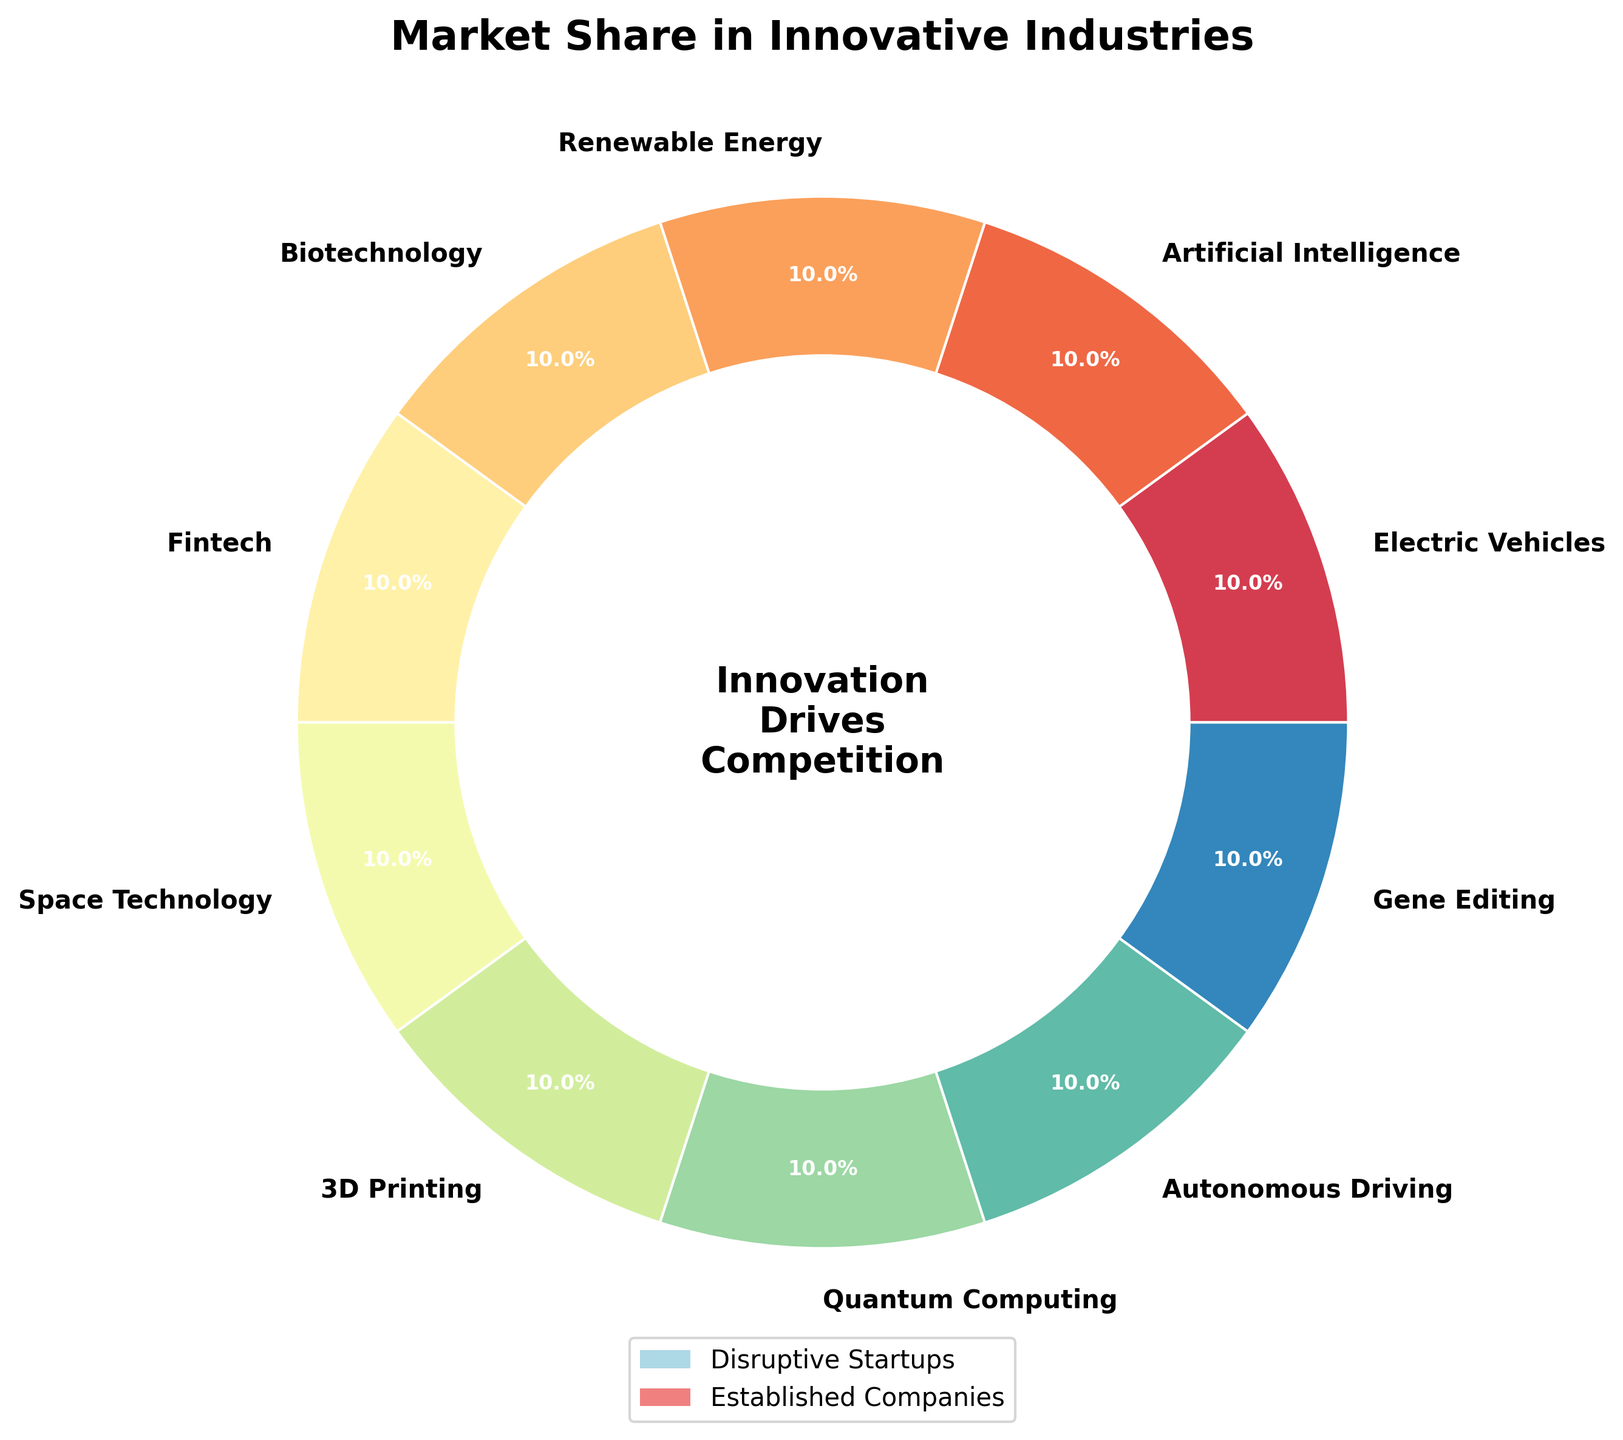What percentage of the market do disruptive startups capture in the Electric Vehicles industry? Look at the Electric Vehicles section of the pie chart. It shows that disruptive startups capture 37% of the market.
Answer: 37% Which industry has the smallest market share for disruptive startups? Examine all sections of the pie chart and identify the industry with the lowest percentage for disruptive startups. It is Quantum Computing with 25%.
Answer: Quantum Computing Compare the market shares of disruptive startups in Fintech and Renewable Energy. Which one has a higher market share? Look at the Fintech and Renewable Energy sections of the pie chart. Fintech has a 45% market share for disruptive startups, whereas Renewable Energy has 31%. Therefore, Fintech has a higher market share.
Answer: Fintech Which industries have a higher market share for disruptive startups than established companies? Identify sections where the disruptive startups’ percentage is greater than that of established companies. This is true for Artificial Intelligence (42% vs. 58%) and Fintech (45% vs. 55%).
Answer: Artificial Intelligence, Fintech What is the median market share percentage of disruptive startups across all industries? Arrange the disruptive startups' percentages in ascending order: 25%, 28%, 30%, 31%, 33%, 35%, 37%, 39%, 42%, 45%. The median is the average of the middle two numbers (33% and 35%), so (33 + 35) / 2 = 34%.
Answer: 34% How much higher is the market share for established companies in the Biotechnology industry compared to disruptive startups? Look at the Biotechnology section. Established companies have 72%, and disruptive startups have 28%. The difference is 72% - 28% = 44%.
Answer: 44% Which industry has the largest discrepancy between the market shares of disruptive startups and established companies? For each industry, calculate the absolute difference between disruptive startups' and established companies' percentages. The largest discrepancy is in Quantum Computing, with a difference of 75% - 25% = 50%.
Answer: Quantum Computing What is the combined market share of disruptive startups in Electric Vehicles and Space Technology? Add the disruptive startups' percentages for Electric Vehicles (37%) and Space Technology (39%). The combined market share is 37% + 39% = 76%.
Answer: 76% Is the market share of disruptive startups in Autonomous Driving higher or lower than in 3D Printing, and by how much? Look at the Autonomous Driving and 3D Printing sections. Disruptive startups' share in Autonomous Driving is 35%, and in 3D Printing, it is 33%. The difference is 35% - 33% = 2%.
Answer: Higher by 2% 